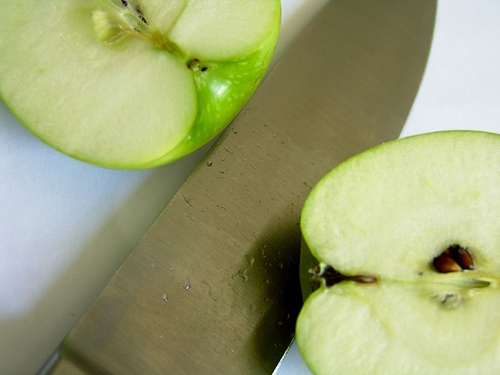Describe the objects in this image and their specific colors. I can see knife in lightgreen, olive, and black tones, apple in lightgreen, khaki, and black tones, and apple in lightgreen and khaki tones in this image. 